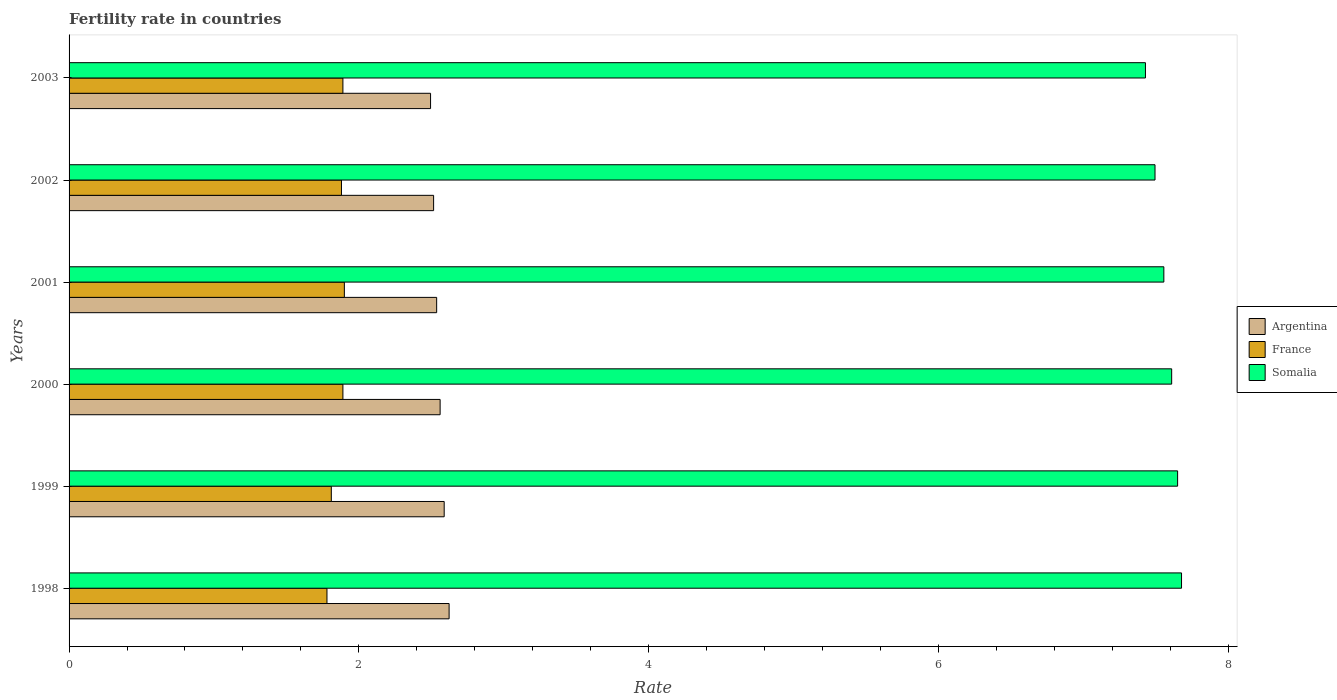Are the number of bars per tick equal to the number of legend labels?
Offer a terse response. Yes. What is the label of the 2nd group of bars from the top?
Your answer should be compact. 2002. What is the fertility rate in France in 2000?
Make the answer very short. 1.89. Across all years, what is the minimum fertility rate in Argentina?
Offer a terse response. 2.5. What is the total fertility rate in Argentina in the graph?
Your response must be concise. 15.32. What is the difference between the fertility rate in Argentina in 2002 and that in 2003?
Your answer should be compact. 0.02. What is the difference between the fertility rate in Argentina in 1999 and the fertility rate in Somalia in 2003?
Provide a succinct answer. -4.84. What is the average fertility rate in France per year?
Your response must be concise. 1.86. In the year 2003, what is the difference between the fertility rate in France and fertility rate in Argentina?
Your answer should be very brief. -0.61. In how many years, is the fertility rate in Argentina greater than 7.2 ?
Provide a short and direct response. 0. What is the ratio of the fertility rate in Somalia in 2001 to that in 2002?
Offer a very short reply. 1.01. Is the fertility rate in Argentina in 1998 less than that in 2003?
Ensure brevity in your answer.  No. What is the difference between the highest and the second highest fertility rate in France?
Your answer should be very brief. 0.01. What is the difference between the highest and the lowest fertility rate in Argentina?
Keep it short and to the point. 0.13. In how many years, is the fertility rate in Argentina greater than the average fertility rate in Argentina taken over all years?
Provide a short and direct response. 3. What does the 3rd bar from the bottom in 1999 represents?
Offer a very short reply. Somalia. Is it the case that in every year, the sum of the fertility rate in Somalia and fertility rate in Argentina is greater than the fertility rate in France?
Ensure brevity in your answer.  Yes. How many bars are there?
Give a very brief answer. 18. Are all the bars in the graph horizontal?
Ensure brevity in your answer.  Yes. How many years are there in the graph?
Keep it short and to the point. 6. Are the values on the major ticks of X-axis written in scientific E-notation?
Make the answer very short. No. Does the graph contain grids?
Your response must be concise. No. Where does the legend appear in the graph?
Make the answer very short. Center right. What is the title of the graph?
Give a very brief answer. Fertility rate in countries. Does "Macedonia" appear as one of the legend labels in the graph?
Offer a very short reply. No. What is the label or title of the X-axis?
Keep it short and to the point. Rate. What is the Rate of Argentina in 1998?
Your answer should be compact. 2.62. What is the Rate of France in 1998?
Keep it short and to the point. 1.78. What is the Rate of Somalia in 1998?
Your answer should be very brief. 7.68. What is the Rate in Argentina in 1999?
Ensure brevity in your answer.  2.59. What is the Rate of France in 1999?
Keep it short and to the point. 1.81. What is the Rate of Somalia in 1999?
Provide a succinct answer. 7.65. What is the Rate in Argentina in 2000?
Provide a short and direct response. 2.56. What is the Rate of France in 2000?
Your answer should be compact. 1.89. What is the Rate in Somalia in 2000?
Offer a terse response. 7.61. What is the Rate of Argentina in 2001?
Give a very brief answer. 2.54. What is the Rate of France in 2001?
Give a very brief answer. 1.9. What is the Rate in Somalia in 2001?
Ensure brevity in your answer.  7.56. What is the Rate in Argentina in 2002?
Your response must be concise. 2.52. What is the Rate of France in 2002?
Keep it short and to the point. 1.88. What is the Rate in Somalia in 2002?
Offer a terse response. 7.5. What is the Rate of Argentina in 2003?
Make the answer very short. 2.5. What is the Rate of France in 2003?
Ensure brevity in your answer.  1.89. What is the Rate in Somalia in 2003?
Make the answer very short. 7.43. Across all years, what is the maximum Rate of Argentina?
Ensure brevity in your answer.  2.62. Across all years, what is the maximum Rate of Somalia?
Make the answer very short. 7.68. Across all years, what is the minimum Rate in Argentina?
Offer a terse response. 2.5. Across all years, what is the minimum Rate of France?
Provide a succinct answer. 1.78. Across all years, what is the minimum Rate in Somalia?
Ensure brevity in your answer.  7.43. What is the total Rate of Argentina in the graph?
Provide a short and direct response. 15.32. What is the total Rate in France in the graph?
Your response must be concise. 11.15. What is the total Rate of Somalia in the graph?
Give a very brief answer. 45.42. What is the difference between the Rate in Argentina in 1998 and that in 1999?
Make the answer very short. 0.03. What is the difference between the Rate in France in 1998 and that in 1999?
Ensure brevity in your answer.  -0.03. What is the difference between the Rate in Somalia in 1998 and that in 1999?
Offer a terse response. 0.03. What is the difference between the Rate in Argentina in 1998 and that in 2000?
Your response must be concise. 0.06. What is the difference between the Rate of France in 1998 and that in 2000?
Offer a terse response. -0.11. What is the difference between the Rate in Somalia in 1998 and that in 2000?
Offer a terse response. 0.07. What is the difference between the Rate in Argentina in 1998 and that in 2001?
Give a very brief answer. 0.09. What is the difference between the Rate in France in 1998 and that in 2001?
Provide a short and direct response. -0.12. What is the difference between the Rate of Somalia in 1998 and that in 2001?
Offer a very short reply. 0.12. What is the difference between the Rate of Argentina in 1998 and that in 2002?
Provide a short and direct response. 0.11. What is the difference between the Rate in Somalia in 1998 and that in 2002?
Offer a terse response. 0.18. What is the difference between the Rate of Argentina in 1998 and that in 2003?
Your answer should be compact. 0.13. What is the difference between the Rate in France in 1998 and that in 2003?
Provide a short and direct response. -0.11. What is the difference between the Rate in Somalia in 1998 and that in 2003?
Offer a very short reply. 0.25. What is the difference between the Rate in Argentina in 1999 and that in 2000?
Offer a terse response. 0.03. What is the difference between the Rate of France in 1999 and that in 2000?
Offer a very short reply. -0.08. What is the difference between the Rate of Somalia in 1999 and that in 2000?
Make the answer very short. 0.04. What is the difference between the Rate of Argentina in 1999 and that in 2001?
Your answer should be very brief. 0.05. What is the difference between the Rate of France in 1999 and that in 2001?
Keep it short and to the point. -0.09. What is the difference between the Rate of Somalia in 1999 and that in 2001?
Make the answer very short. 0.1. What is the difference between the Rate of Argentina in 1999 and that in 2002?
Offer a very short reply. 0.07. What is the difference between the Rate in France in 1999 and that in 2002?
Offer a very short reply. -0.07. What is the difference between the Rate of Somalia in 1999 and that in 2002?
Your answer should be compact. 0.16. What is the difference between the Rate in Argentina in 1999 and that in 2003?
Make the answer very short. 0.09. What is the difference between the Rate in France in 1999 and that in 2003?
Keep it short and to the point. -0.08. What is the difference between the Rate of Somalia in 1999 and that in 2003?
Keep it short and to the point. 0.22. What is the difference between the Rate of Argentina in 2000 and that in 2001?
Make the answer very short. 0.02. What is the difference between the Rate of France in 2000 and that in 2001?
Make the answer very short. -0.01. What is the difference between the Rate of Somalia in 2000 and that in 2001?
Provide a succinct answer. 0.05. What is the difference between the Rate in Argentina in 2000 and that in 2002?
Keep it short and to the point. 0.04. What is the difference between the Rate of Somalia in 2000 and that in 2002?
Offer a very short reply. 0.12. What is the difference between the Rate in Argentina in 2000 and that in 2003?
Your answer should be very brief. 0.07. What is the difference between the Rate of Somalia in 2000 and that in 2003?
Give a very brief answer. 0.18. What is the difference between the Rate of Argentina in 2001 and that in 2002?
Your answer should be very brief. 0.02. What is the difference between the Rate in Somalia in 2001 and that in 2002?
Your answer should be compact. 0.06. What is the difference between the Rate in Argentina in 2001 and that in 2003?
Make the answer very short. 0.04. What is the difference between the Rate of Somalia in 2001 and that in 2003?
Ensure brevity in your answer.  0.13. What is the difference between the Rate of Argentina in 2002 and that in 2003?
Give a very brief answer. 0.02. What is the difference between the Rate in France in 2002 and that in 2003?
Your answer should be very brief. -0.01. What is the difference between the Rate of Somalia in 2002 and that in 2003?
Provide a succinct answer. 0.07. What is the difference between the Rate in Argentina in 1998 and the Rate in France in 1999?
Your response must be concise. 0.81. What is the difference between the Rate in Argentina in 1998 and the Rate in Somalia in 1999?
Offer a terse response. -5.03. What is the difference between the Rate of France in 1998 and the Rate of Somalia in 1999?
Offer a terse response. -5.87. What is the difference between the Rate in Argentina in 1998 and the Rate in France in 2000?
Provide a short and direct response. 0.73. What is the difference between the Rate of Argentina in 1998 and the Rate of Somalia in 2000?
Ensure brevity in your answer.  -4.99. What is the difference between the Rate in France in 1998 and the Rate in Somalia in 2000?
Offer a terse response. -5.83. What is the difference between the Rate in Argentina in 1998 and the Rate in France in 2001?
Provide a succinct answer. 0.72. What is the difference between the Rate in Argentina in 1998 and the Rate in Somalia in 2001?
Provide a short and direct response. -4.93. What is the difference between the Rate of France in 1998 and the Rate of Somalia in 2001?
Provide a succinct answer. -5.78. What is the difference between the Rate in Argentina in 1998 and the Rate in France in 2002?
Make the answer very short. 0.74. What is the difference between the Rate in Argentina in 1998 and the Rate in Somalia in 2002?
Your answer should be very brief. -4.87. What is the difference between the Rate of France in 1998 and the Rate of Somalia in 2002?
Keep it short and to the point. -5.71. What is the difference between the Rate of Argentina in 1998 and the Rate of France in 2003?
Ensure brevity in your answer.  0.73. What is the difference between the Rate of Argentina in 1998 and the Rate of Somalia in 2003?
Ensure brevity in your answer.  -4.81. What is the difference between the Rate in France in 1998 and the Rate in Somalia in 2003?
Keep it short and to the point. -5.65. What is the difference between the Rate of Argentina in 1999 and the Rate of France in 2000?
Keep it short and to the point. 0.7. What is the difference between the Rate of Argentina in 1999 and the Rate of Somalia in 2000?
Your response must be concise. -5.02. What is the difference between the Rate in France in 1999 and the Rate in Somalia in 2000?
Give a very brief answer. -5.8. What is the difference between the Rate in Argentina in 1999 and the Rate in France in 2001?
Offer a terse response. 0.69. What is the difference between the Rate in Argentina in 1999 and the Rate in Somalia in 2001?
Your answer should be very brief. -4.97. What is the difference between the Rate in France in 1999 and the Rate in Somalia in 2001?
Provide a short and direct response. -5.75. What is the difference between the Rate of Argentina in 1999 and the Rate of France in 2002?
Offer a terse response. 0.71. What is the difference between the Rate in Argentina in 1999 and the Rate in Somalia in 2002?
Your answer should be very brief. -4.91. What is the difference between the Rate of France in 1999 and the Rate of Somalia in 2002?
Provide a succinct answer. -5.68. What is the difference between the Rate of Argentina in 1999 and the Rate of France in 2003?
Make the answer very short. 0.7. What is the difference between the Rate of Argentina in 1999 and the Rate of Somalia in 2003?
Provide a succinct answer. -4.84. What is the difference between the Rate in France in 1999 and the Rate in Somalia in 2003?
Keep it short and to the point. -5.62. What is the difference between the Rate in Argentina in 2000 and the Rate in France in 2001?
Provide a succinct answer. 0.66. What is the difference between the Rate in Argentina in 2000 and the Rate in Somalia in 2001?
Provide a succinct answer. -5. What is the difference between the Rate in France in 2000 and the Rate in Somalia in 2001?
Make the answer very short. -5.67. What is the difference between the Rate of Argentina in 2000 and the Rate of France in 2002?
Make the answer very short. 0.68. What is the difference between the Rate in Argentina in 2000 and the Rate in Somalia in 2002?
Provide a short and direct response. -4.93. What is the difference between the Rate of France in 2000 and the Rate of Somalia in 2002?
Give a very brief answer. -5.61. What is the difference between the Rate in Argentina in 2000 and the Rate in France in 2003?
Your response must be concise. 0.67. What is the difference between the Rate of Argentina in 2000 and the Rate of Somalia in 2003?
Offer a very short reply. -4.87. What is the difference between the Rate in France in 2000 and the Rate in Somalia in 2003?
Provide a succinct answer. -5.54. What is the difference between the Rate of Argentina in 2001 and the Rate of France in 2002?
Give a very brief answer. 0.66. What is the difference between the Rate in Argentina in 2001 and the Rate in Somalia in 2002?
Give a very brief answer. -4.96. What is the difference between the Rate in France in 2001 and the Rate in Somalia in 2002?
Make the answer very short. -5.59. What is the difference between the Rate in Argentina in 2001 and the Rate in France in 2003?
Provide a short and direct response. 0.65. What is the difference between the Rate of Argentina in 2001 and the Rate of Somalia in 2003?
Keep it short and to the point. -4.89. What is the difference between the Rate in France in 2001 and the Rate in Somalia in 2003?
Provide a short and direct response. -5.53. What is the difference between the Rate in Argentina in 2002 and the Rate in France in 2003?
Offer a terse response. 0.63. What is the difference between the Rate in Argentina in 2002 and the Rate in Somalia in 2003?
Keep it short and to the point. -4.91. What is the difference between the Rate in France in 2002 and the Rate in Somalia in 2003?
Your answer should be very brief. -5.55. What is the average Rate in Argentina per year?
Provide a short and direct response. 2.55. What is the average Rate in France per year?
Give a very brief answer. 1.86. What is the average Rate in Somalia per year?
Offer a terse response. 7.57. In the year 1998, what is the difference between the Rate in Argentina and Rate in France?
Offer a terse response. 0.84. In the year 1998, what is the difference between the Rate in Argentina and Rate in Somalia?
Provide a succinct answer. -5.05. In the year 1998, what is the difference between the Rate in France and Rate in Somalia?
Offer a very short reply. -5.9. In the year 1999, what is the difference between the Rate in Argentina and Rate in France?
Offer a very short reply. 0.78. In the year 1999, what is the difference between the Rate in Argentina and Rate in Somalia?
Offer a terse response. -5.06. In the year 1999, what is the difference between the Rate of France and Rate of Somalia?
Ensure brevity in your answer.  -5.84. In the year 2000, what is the difference between the Rate in Argentina and Rate in France?
Give a very brief answer. 0.67. In the year 2000, what is the difference between the Rate in Argentina and Rate in Somalia?
Make the answer very short. -5.05. In the year 2000, what is the difference between the Rate in France and Rate in Somalia?
Your answer should be compact. -5.72. In the year 2001, what is the difference between the Rate in Argentina and Rate in France?
Offer a terse response. 0.64. In the year 2001, what is the difference between the Rate of Argentina and Rate of Somalia?
Your response must be concise. -5.02. In the year 2001, what is the difference between the Rate of France and Rate of Somalia?
Your response must be concise. -5.66. In the year 2002, what is the difference between the Rate of Argentina and Rate of France?
Make the answer very short. 0.64. In the year 2002, what is the difference between the Rate of Argentina and Rate of Somalia?
Your response must be concise. -4.98. In the year 2002, what is the difference between the Rate of France and Rate of Somalia?
Ensure brevity in your answer.  -5.62. In the year 2003, what is the difference between the Rate of Argentina and Rate of France?
Your answer should be compact. 0.6. In the year 2003, what is the difference between the Rate in Argentina and Rate in Somalia?
Your answer should be compact. -4.93. In the year 2003, what is the difference between the Rate in France and Rate in Somalia?
Ensure brevity in your answer.  -5.54. What is the ratio of the Rate of Argentina in 1998 to that in 1999?
Provide a short and direct response. 1.01. What is the ratio of the Rate of France in 1998 to that in 1999?
Provide a succinct answer. 0.98. What is the ratio of the Rate of Somalia in 1998 to that in 1999?
Your response must be concise. 1. What is the ratio of the Rate in Argentina in 1998 to that in 2000?
Your answer should be very brief. 1.02. What is the ratio of the Rate of France in 1998 to that in 2000?
Offer a terse response. 0.94. What is the ratio of the Rate in Somalia in 1998 to that in 2000?
Provide a short and direct response. 1.01. What is the ratio of the Rate in Argentina in 1998 to that in 2001?
Ensure brevity in your answer.  1.03. What is the ratio of the Rate in France in 1998 to that in 2001?
Provide a succinct answer. 0.94. What is the ratio of the Rate in Somalia in 1998 to that in 2001?
Your response must be concise. 1.02. What is the ratio of the Rate of Argentina in 1998 to that in 2002?
Offer a very short reply. 1.04. What is the ratio of the Rate in France in 1998 to that in 2002?
Your response must be concise. 0.95. What is the ratio of the Rate of Somalia in 1998 to that in 2002?
Make the answer very short. 1.02. What is the ratio of the Rate in Argentina in 1998 to that in 2003?
Make the answer very short. 1.05. What is the ratio of the Rate in France in 1998 to that in 2003?
Offer a terse response. 0.94. What is the ratio of the Rate in Somalia in 1998 to that in 2003?
Your answer should be very brief. 1.03. What is the ratio of the Rate in Argentina in 1999 to that in 2000?
Ensure brevity in your answer.  1.01. What is the ratio of the Rate in France in 1999 to that in 2000?
Provide a succinct answer. 0.96. What is the ratio of the Rate in Somalia in 1999 to that in 2000?
Your response must be concise. 1.01. What is the ratio of the Rate in Argentina in 1999 to that in 2001?
Give a very brief answer. 1.02. What is the ratio of the Rate of France in 1999 to that in 2001?
Provide a succinct answer. 0.95. What is the ratio of the Rate of Somalia in 1999 to that in 2001?
Keep it short and to the point. 1.01. What is the ratio of the Rate in France in 1999 to that in 2002?
Provide a succinct answer. 0.96. What is the ratio of the Rate of Somalia in 1999 to that in 2002?
Provide a short and direct response. 1.02. What is the ratio of the Rate in Argentina in 1999 to that in 2003?
Give a very brief answer. 1.04. What is the ratio of the Rate in France in 1999 to that in 2003?
Ensure brevity in your answer.  0.96. What is the ratio of the Rate of Somalia in 1999 to that in 2003?
Give a very brief answer. 1.03. What is the ratio of the Rate of Argentina in 2000 to that in 2001?
Ensure brevity in your answer.  1.01. What is the ratio of the Rate in Somalia in 2000 to that in 2001?
Provide a short and direct response. 1.01. What is the ratio of the Rate of Argentina in 2000 to that in 2002?
Your answer should be very brief. 1.02. What is the ratio of the Rate in Somalia in 2000 to that in 2002?
Ensure brevity in your answer.  1.02. What is the ratio of the Rate of Argentina in 2000 to that in 2003?
Your response must be concise. 1.03. What is the ratio of the Rate of France in 2000 to that in 2003?
Your response must be concise. 1. What is the ratio of the Rate of Somalia in 2000 to that in 2003?
Provide a short and direct response. 1.02. What is the ratio of the Rate of Argentina in 2001 to that in 2002?
Offer a very short reply. 1.01. What is the ratio of the Rate of France in 2001 to that in 2002?
Your response must be concise. 1.01. What is the ratio of the Rate in Somalia in 2001 to that in 2002?
Provide a succinct answer. 1.01. What is the ratio of the Rate of Argentina in 2001 to that in 2003?
Your response must be concise. 1.02. What is the ratio of the Rate in France in 2001 to that in 2003?
Your answer should be very brief. 1.01. What is the ratio of the Rate of Somalia in 2001 to that in 2003?
Your answer should be very brief. 1.02. What is the ratio of the Rate of Argentina in 2002 to that in 2003?
Offer a terse response. 1.01. What is the ratio of the Rate in France in 2002 to that in 2003?
Your response must be concise. 0.99. What is the ratio of the Rate in Somalia in 2002 to that in 2003?
Provide a short and direct response. 1.01. What is the difference between the highest and the second highest Rate in Argentina?
Your answer should be very brief. 0.03. What is the difference between the highest and the second highest Rate of Somalia?
Offer a terse response. 0.03. What is the difference between the highest and the lowest Rate of Argentina?
Your response must be concise. 0.13. What is the difference between the highest and the lowest Rate in France?
Offer a terse response. 0.12. What is the difference between the highest and the lowest Rate of Somalia?
Give a very brief answer. 0.25. 